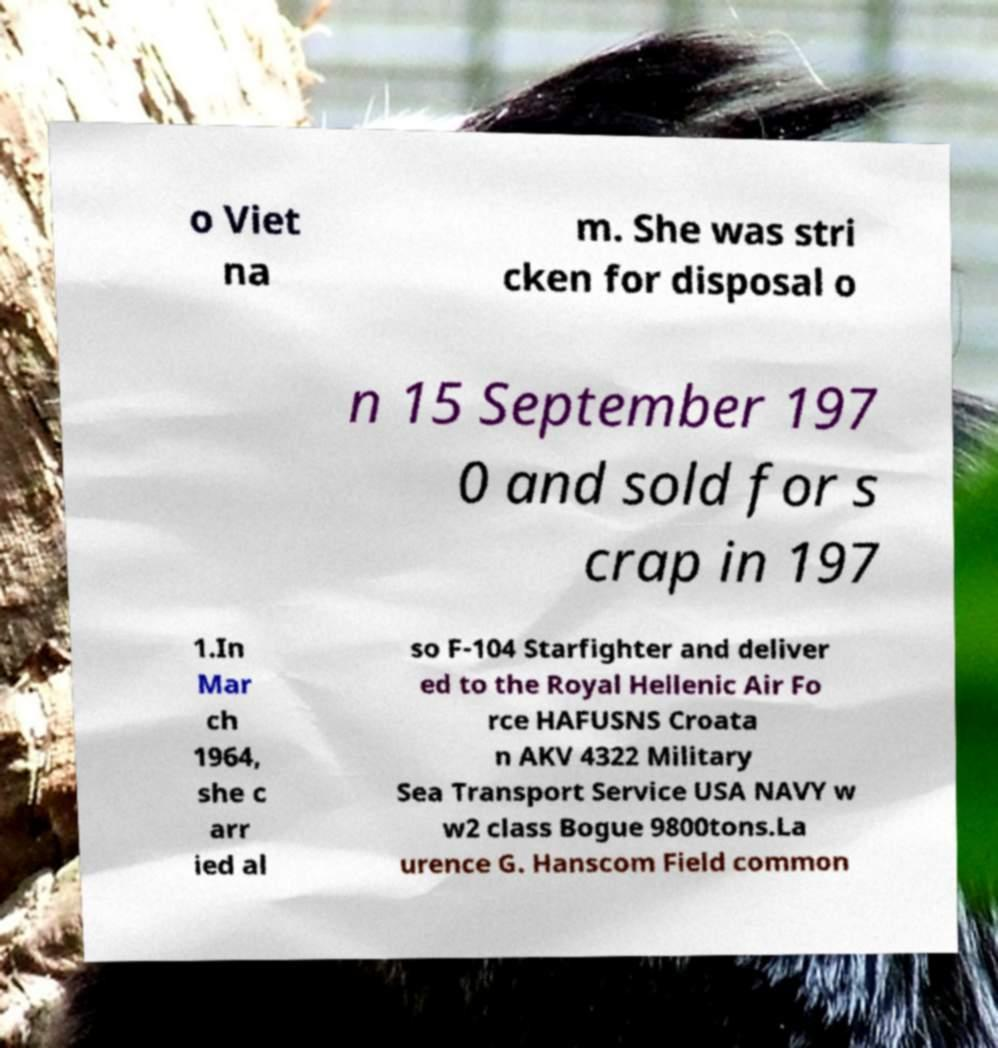There's text embedded in this image that I need extracted. Can you transcribe it verbatim? o Viet na m. She was stri cken for disposal o n 15 September 197 0 and sold for s crap in 197 1.In Mar ch 1964, she c arr ied al so F-104 Starfighter and deliver ed to the Royal Hellenic Air Fo rce HAFUSNS Croata n AKV 4322 Military Sea Transport Service USA NAVY w w2 class Bogue 9800tons.La urence G. Hanscom Field common 